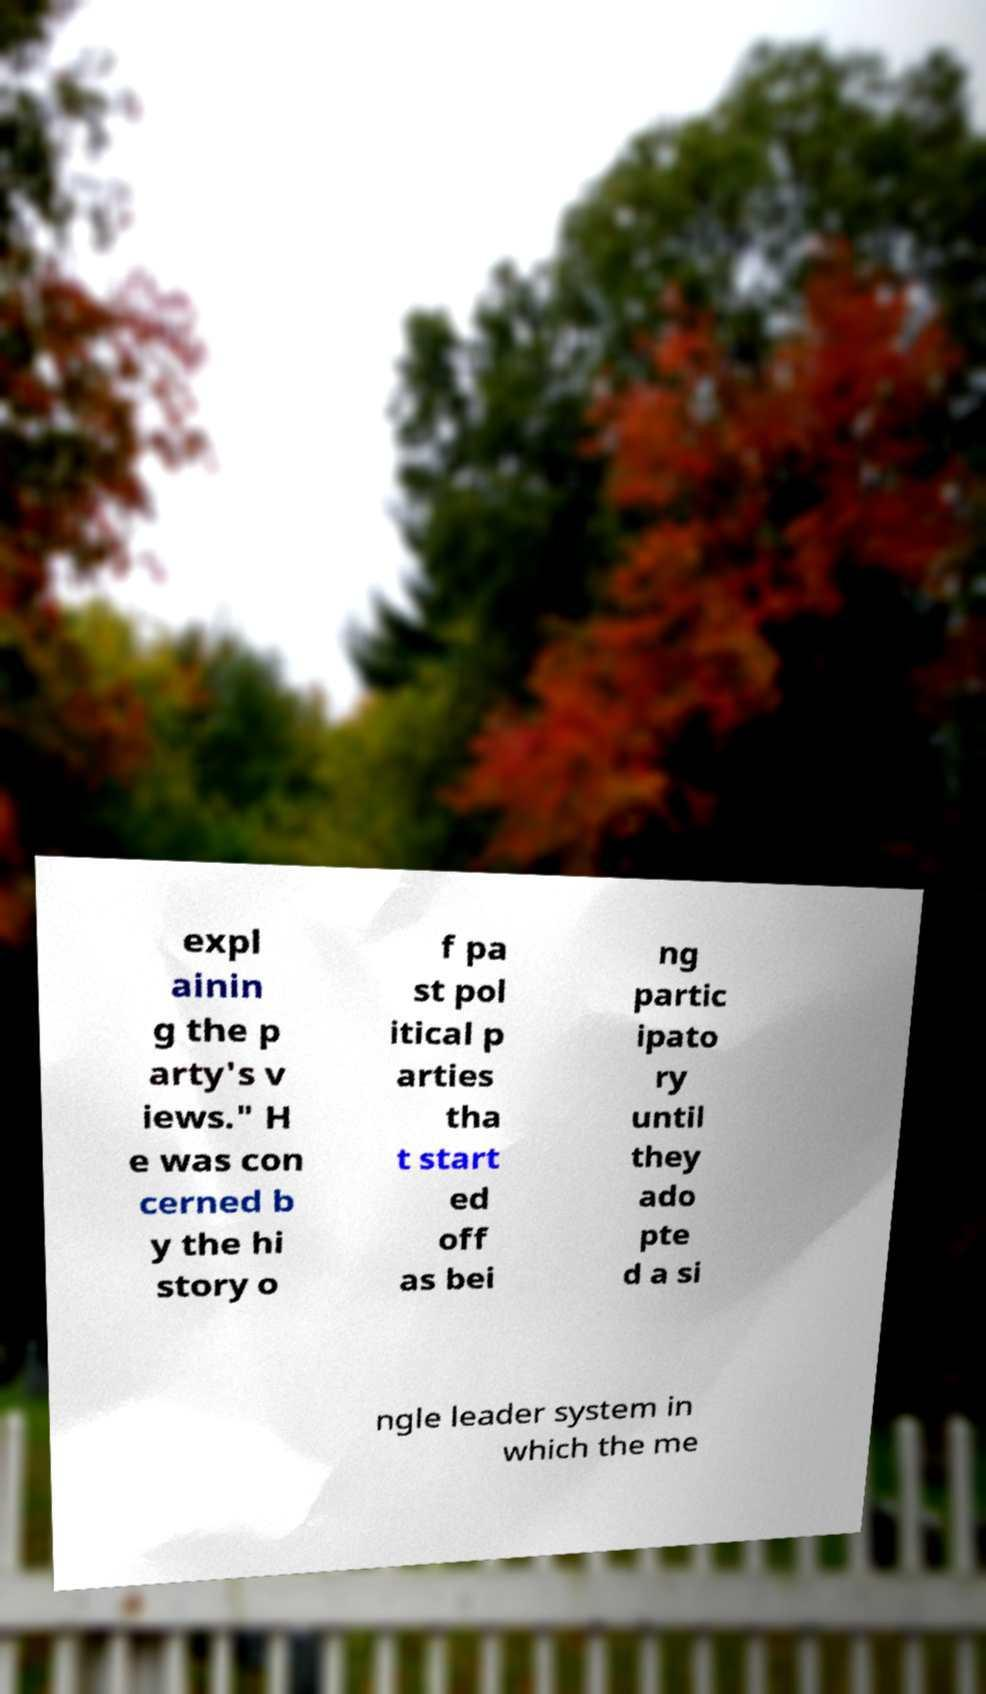Please identify and transcribe the text found in this image. expl ainin g the p arty's v iews." H e was con cerned b y the hi story o f pa st pol itical p arties tha t start ed off as bei ng partic ipato ry until they ado pte d a si ngle leader system in which the me 